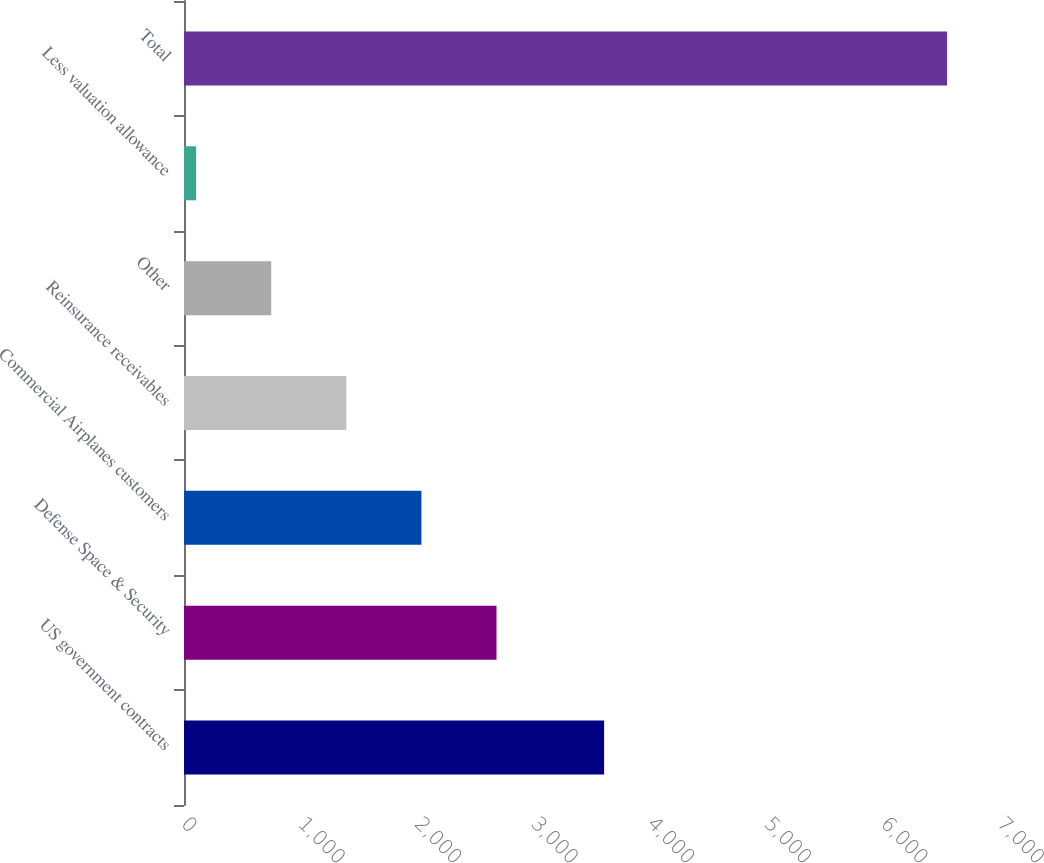<chart> <loc_0><loc_0><loc_500><loc_500><bar_chart><fcel>US government contracts<fcel>Defense Space & Security<fcel>Commercial Airplanes customers<fcel>Reinsurance receivables<fcel>Other<fcel>Less valuation allowance<fcel>Total<nl><fcel>3604<fcel>2680.8<fcel>2036.6<fcel>1392.4<fcel>748.2<fcel>104<fcel>6546<nl></chart> 